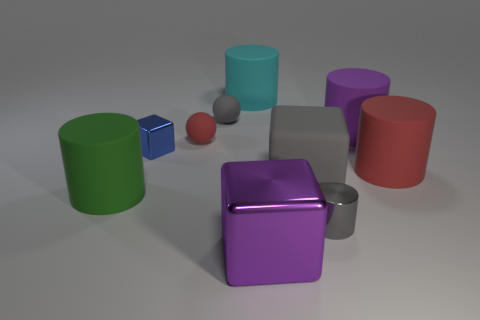There is a big cube that is behind the purple thing that is in front of the small metallic block; are there any red matte things on the right side of it?
Provide a succinct answer. Yes. The big cylinder behind the small gray object that is behind the blue cube is made of what material?
Your answer should be compact. Rubber. There is a large cylinder that is behind the large red rubber cylinder and to the right of the large purple metallic thing; what material is it made of?
Your answer should be compact. Rubber. Is there a large purple metallic object of the same shape as the large gray object?
Your answer should be compact. Yes. Is there a red object on the left side of the small thing that is in front of the big green object?
Offer a terse response. Yes. How many big gray cubes are the same material as the large cyan cylinder?
Provide a short and direct response. 1. Is there a red thing?
Offer a very short reply. Yes. How many tiny metal blocks have the same color as the large rubber block?
Provide a short and direct response. 0. Is the big cyan thing made of the same material as the cube that is behind the large gray rubber block?
Provide a short and direct response. No. Is the number of small gray objects in front of the small shiny cube greater than the number of tiny purple spheres?
Your answer should be very brief. Yes. 